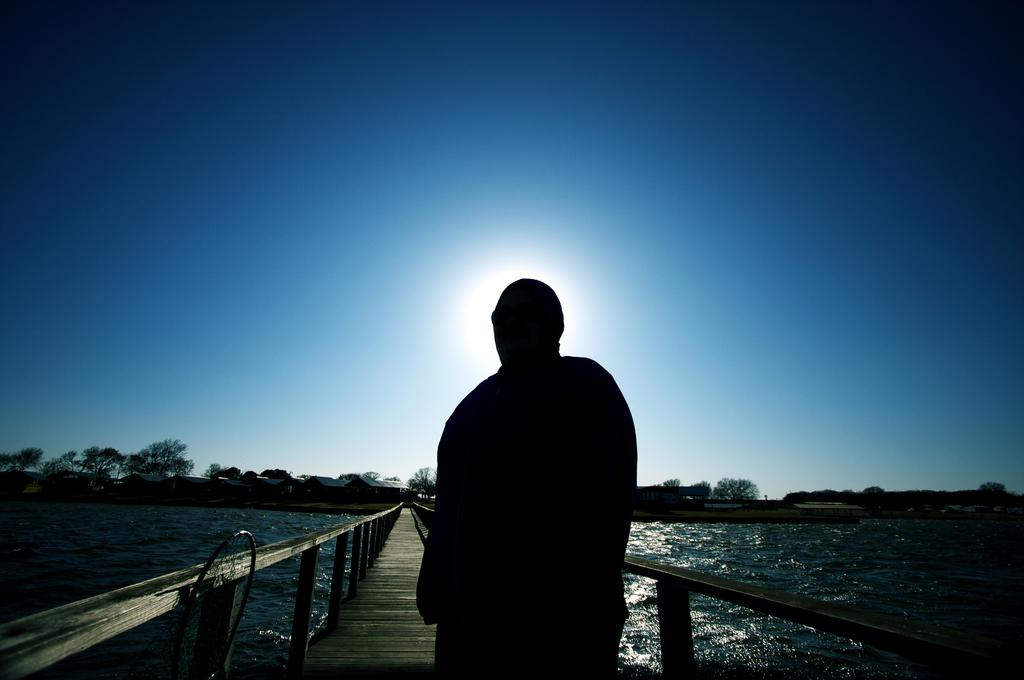What is the main subject of the image? There is a person in the image. What can be seen in the background of the image? There is a bridge, water, trees, houses, and the sky visible in the image. What type of surface is visible in the image? There is ground visible in the image with some objects. What type of furniture can be seen in the image? There is no furniture present in the image. What kind of haircut does the person in the image have? The provided facts do not mention the person's haircut, so it cannot be determined from the image. 